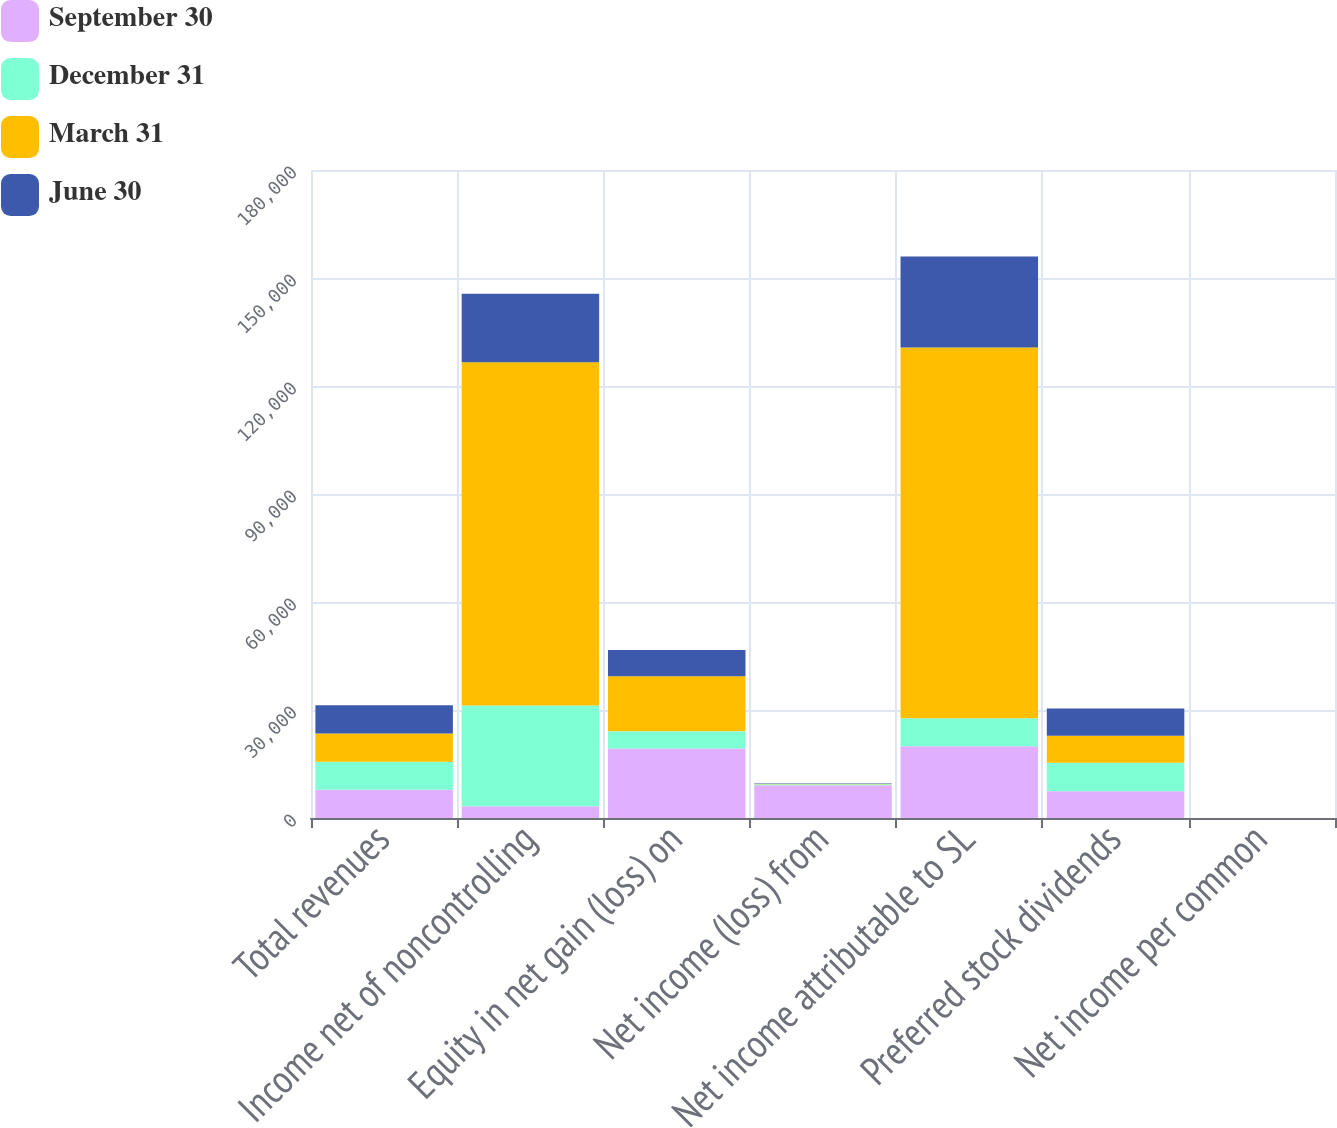Convert chart to OTSL. <chart><loc_0><loc_0><loc_500><loc_500><stacked_bar_chart><ecel><fcel>Total revenues<fcel>Income net of noncontrolling<fcel>Equity in net gain (loss) on<fcel>Net income (loss) from<fcel>Net income attributable to SL<fcel>Preferred stock dividends<fcel>Net income per common<nl><fcel>September 30<fcel>7823.5<fcel>3235<fcel>19277<fcel>9126<fcel>19956<fcel>7407<fcel>0.23<nl><fcel>December 31<fcel>7823.5<fcel>28010<fcel>4807<fcel>217<fcel>7732<fcel>7915<fcel>0.09<nl><fcel>March 31<fcel>7823.5<fcel>95328<fcel>15323<fcel>67<fcel>103040<fcel>7544<fcel>1.15<nl><fcel>June 30<fcel>7823.5<fcel>19074<fcel>7260<fcel>160<fcel>25256<fcel>7545<fcel>0.29<nl></chart> 